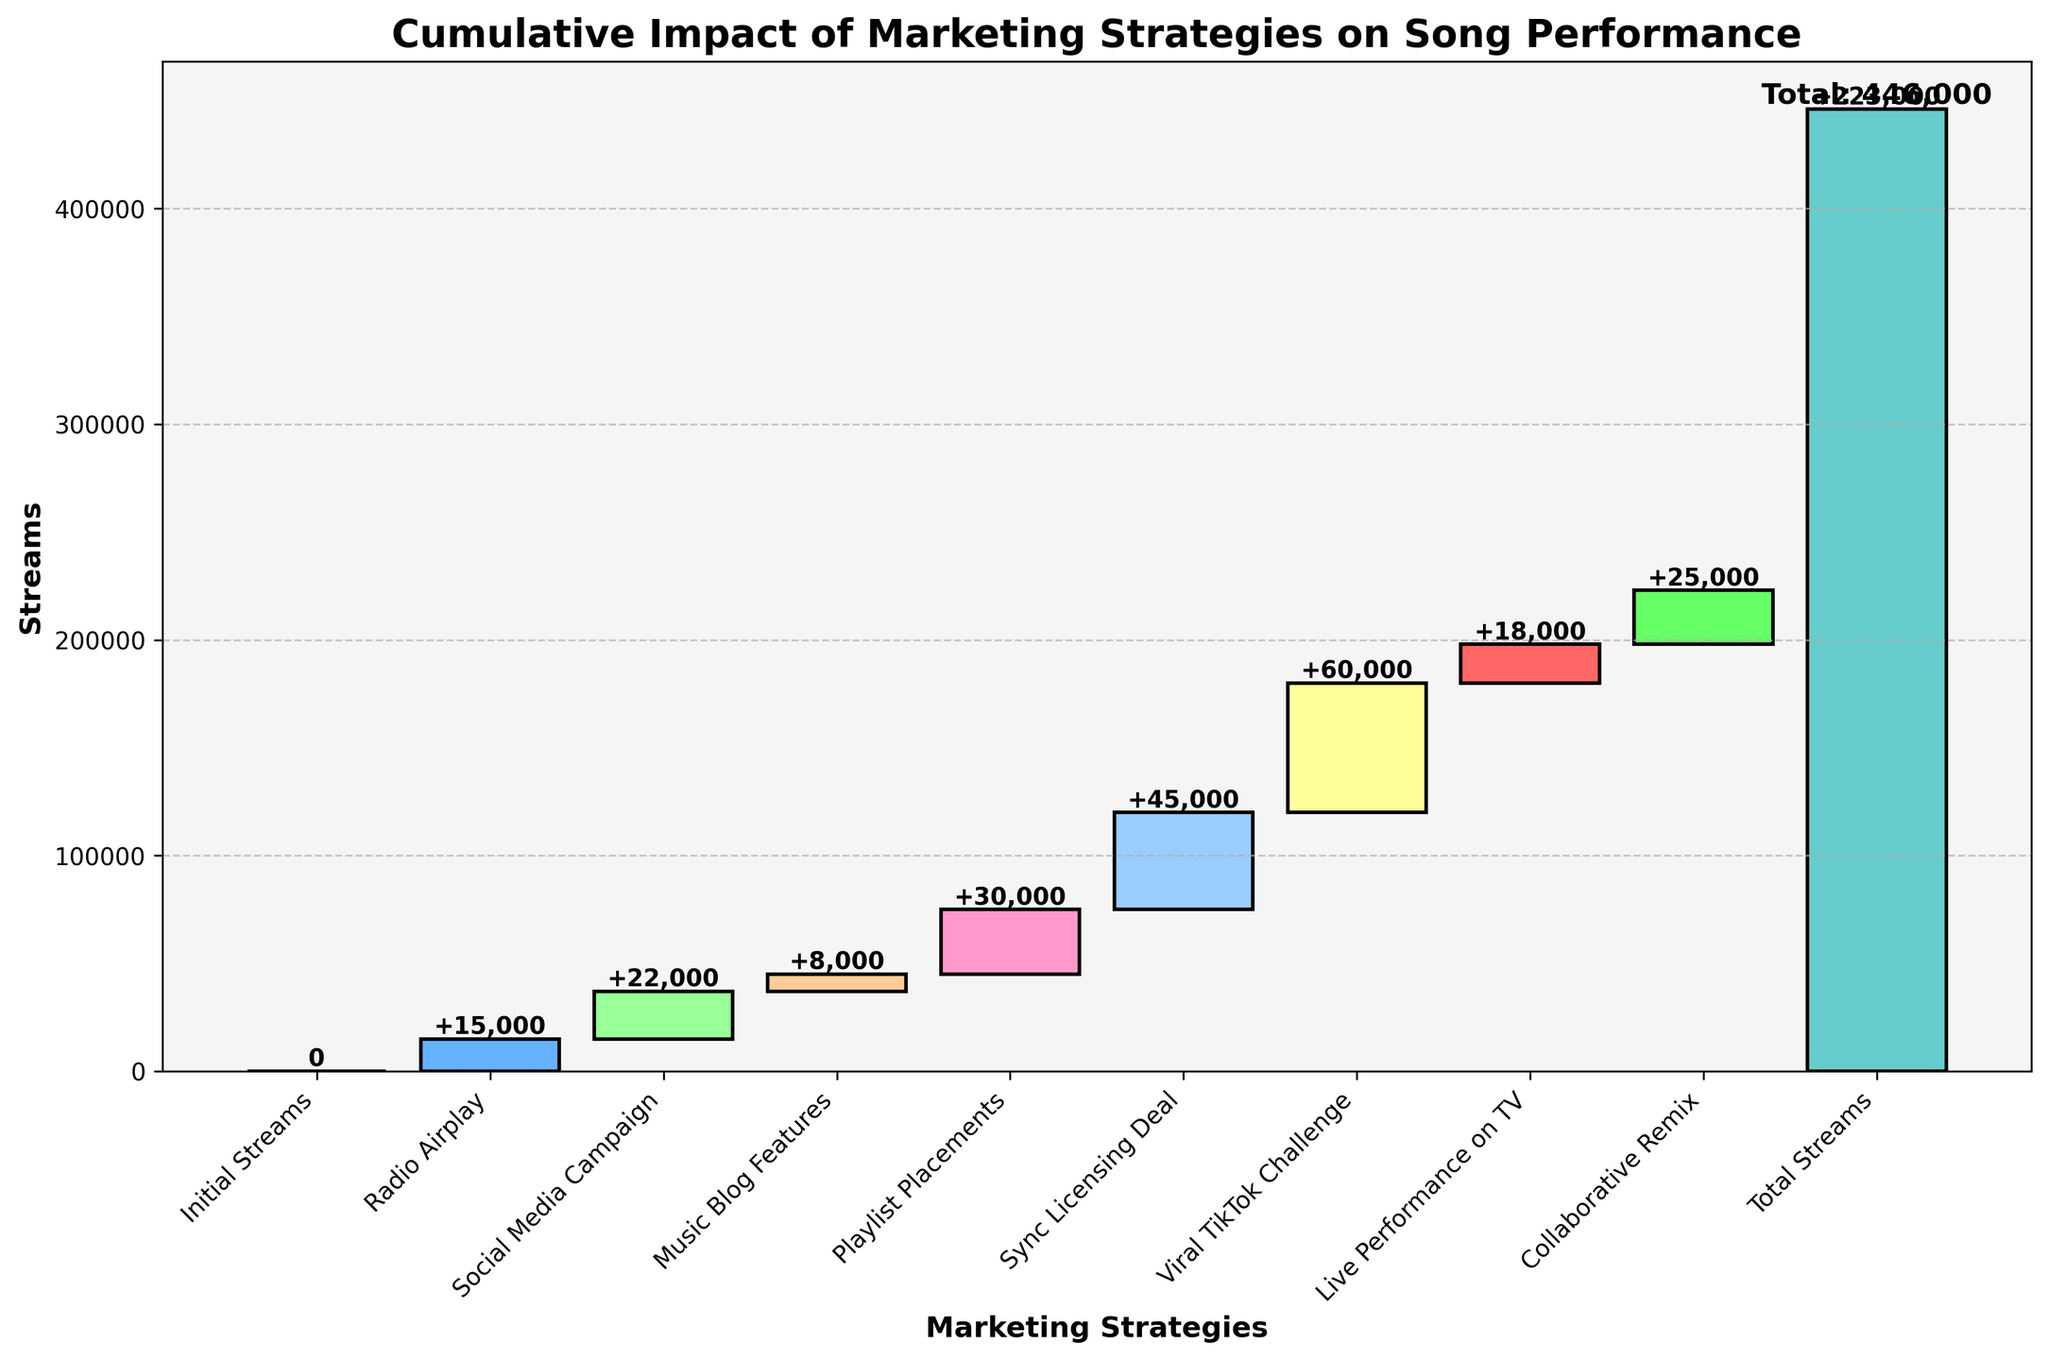What is the title of the figure? The title of the figure is explicitly available at the top.
Answer: Cumulative Impact of Marketing Strategies on Song Performance What is the cumulative impact of the viral TikTok challenge? Find the cumulative impact before the viral TikTok challenge and add its impact to it. The cumulative before it is 125,000, and the TikTok impact is 60,000, so the total is 125,000 + 60,000.
Answer: 185,000 How many marketing strategies contributed to the song's performance? Count the data points excluding the initial streams and total streams because they don't count as marketing strategies.
Answer: 8 Which marketing strategy had the highest impact on song performance? The visual comparison shows that all strategies bars, the viral TikTok challenge bar has the biggest height. This indicates the highest impact.
Answer: Viral TikTok Challenge What is the difference in streams between Radio Airplay and Live Performance on TV? Find the height values of streams for Radio Airplay and Live Performance on TV, then calculate the difference: 18,000 (Live Performance on TV) - 15,000 (Radio Airplay) = 3,000.
Answer: 3,000 What was the cumulative impact before Social Media Campaigns? Find the cumulative impact up to Radio Airplay, which is 15,000 because it accumulates the initial streams 0 and Radio Airplay 15,000.
Answer: 15,000 Which has a greater impact: Sync Licensing Deal or Collaborative Remix? Compare the impact values directly from the figure: Sync Licensing Deal (45,000) is greater than Collaborative Remix (25,000).
Answer: Sync Licensing Deal When did the cumulative streams first exceed 100,000? Add the cumulative values from each strategy until surpassing 100,000: Initial Streams (0) + Radio Airplay (15,000) + Social Media Campaign (22,000) + Music Blog Features (8,000) + Playlist Placements (30,000) + Sync Licensing Deal (45,000) = 120,000, which exceeds 100,000 after Sync Licensing.
Answer: After Sync Licensing Deal What is the total cumulative impact from all the marketing strategies? The figure mentions the total cumulative impact directly: 223,000.
Answer: 223,000 